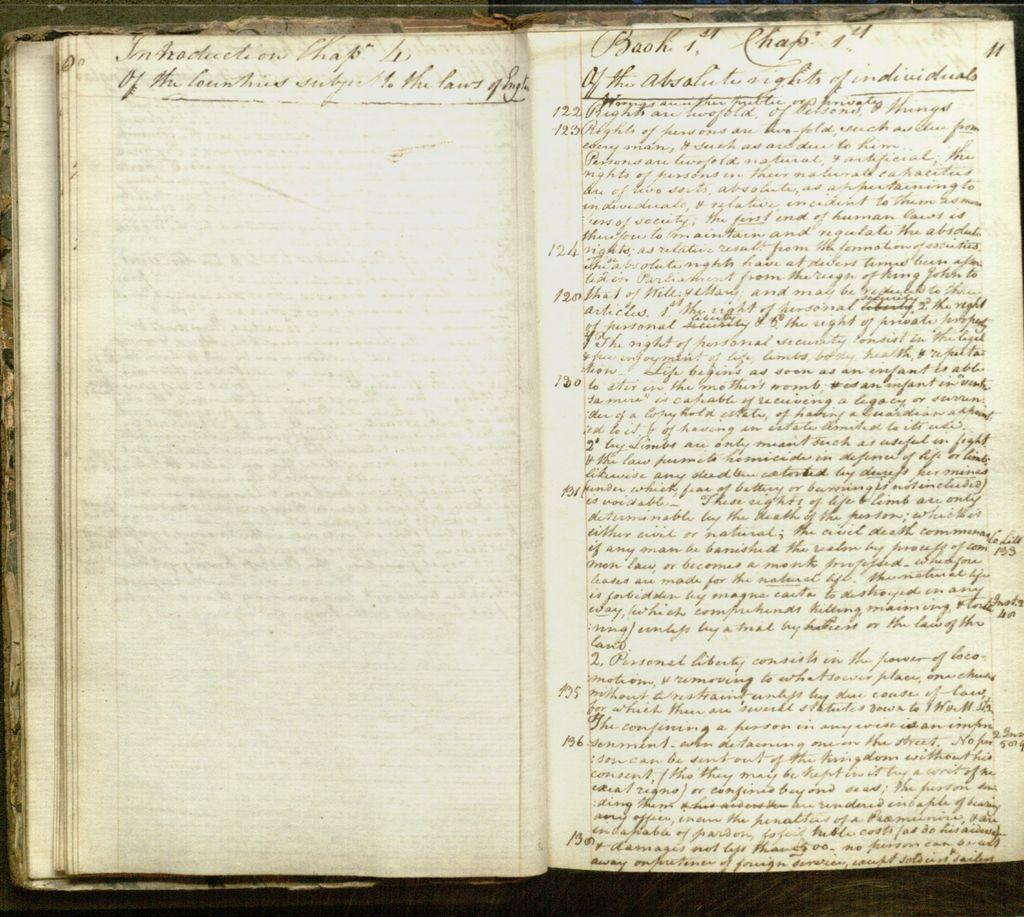<image>
Create a compact narrative representing the image presented. A hand written page reads Chapter 1 at the very top. 